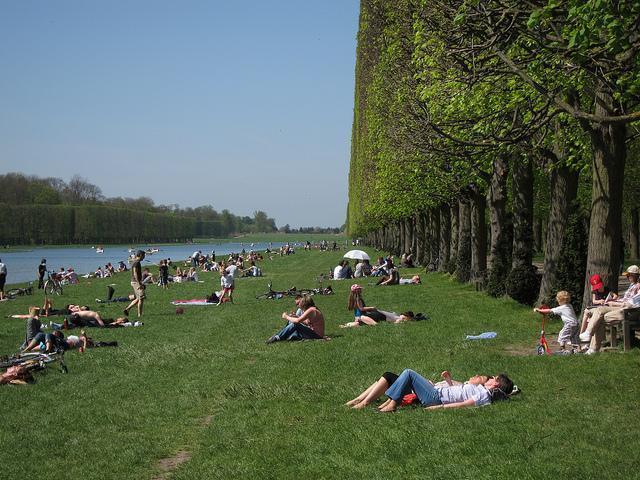How many people are in the picture?
Give a very brief answer. 2. 